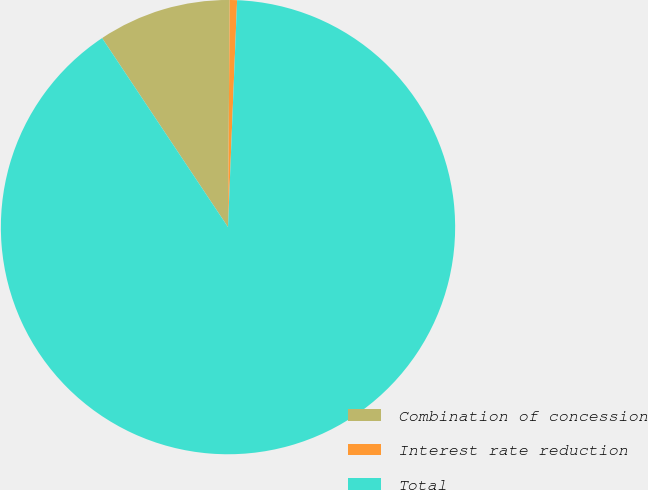Convert chart to OTSL. <chart><loc_0><loc_0><loc_500><loc_500><pie_chart><fcel>Combination of concession<fcel>Interest rate reduction<fcel>Total<nl><fcel>9.47%<fcel>0.52%<fcel>90.01%<nl></chart> 